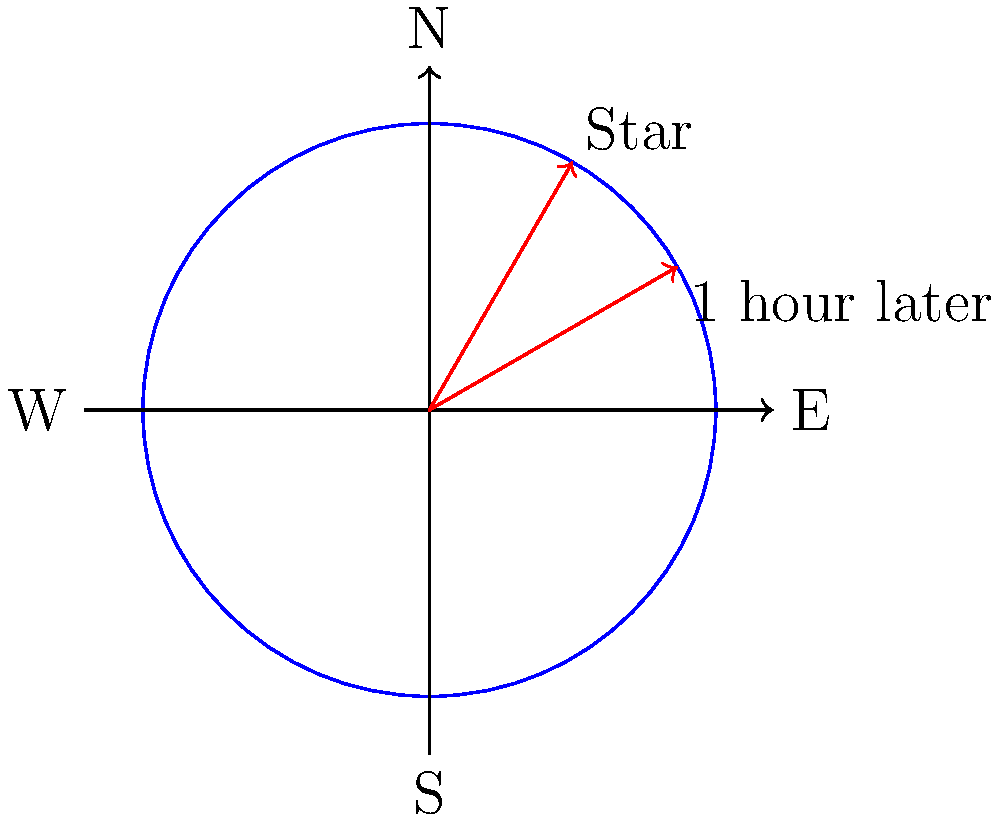As you're planning the layout for your pub's outdoor stargazing area, you notice a bright star's position change over an hour. If the star moves from position A to B as shown in the diagram, in which direction is the star apparently moving across the Portland night sky? Let's break this down step-by-step:

1. The diagram shows a view of the night sky from above, with cardinal directions marked.

2. The star's initial position (A) is at an angle of about 60° from the east, towards the north.

3. After one hour, the star's new position (B) is at an angle of about 30° from the east, towards the north.

4. This change in position is counter-clockwise in the diagram.

5. However, we need to remember that this diagram represents a view from above. From our perspective on Earth looking up at the sky, this motion would appear clockwise.

6. In the northern hemisphere (where Portland is located), stars appear to rotate around the celestial north pole in a clockwise direction when facing north.

7. Given the star's movement from east towards south, we can conclude that the star is moving from east to west in the sky.

8. This apparent motion is due to Earth's rotation from west to east, causing the stars to appear to move west to east.
Answer: East to West 